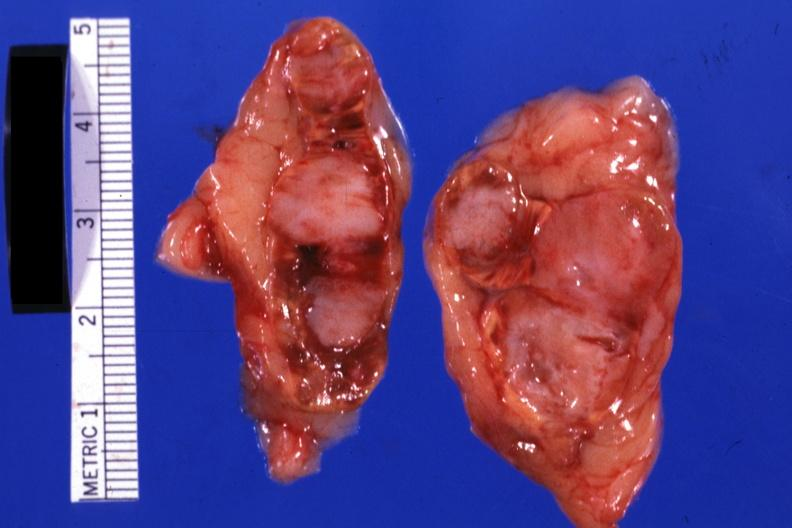what is present?
Answer the question using a single word or phrase. Metastatic carcinoma lung 